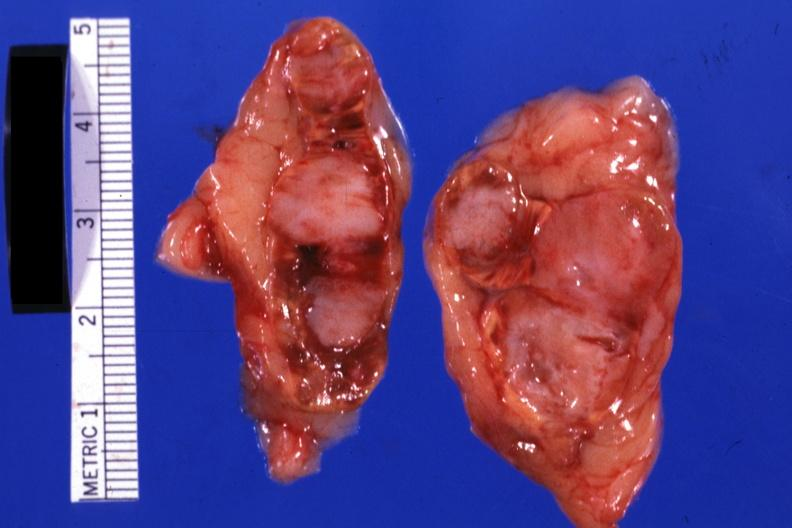what is present?
Answer the question using a single word or phrase. Metastatic carcinoma lung 